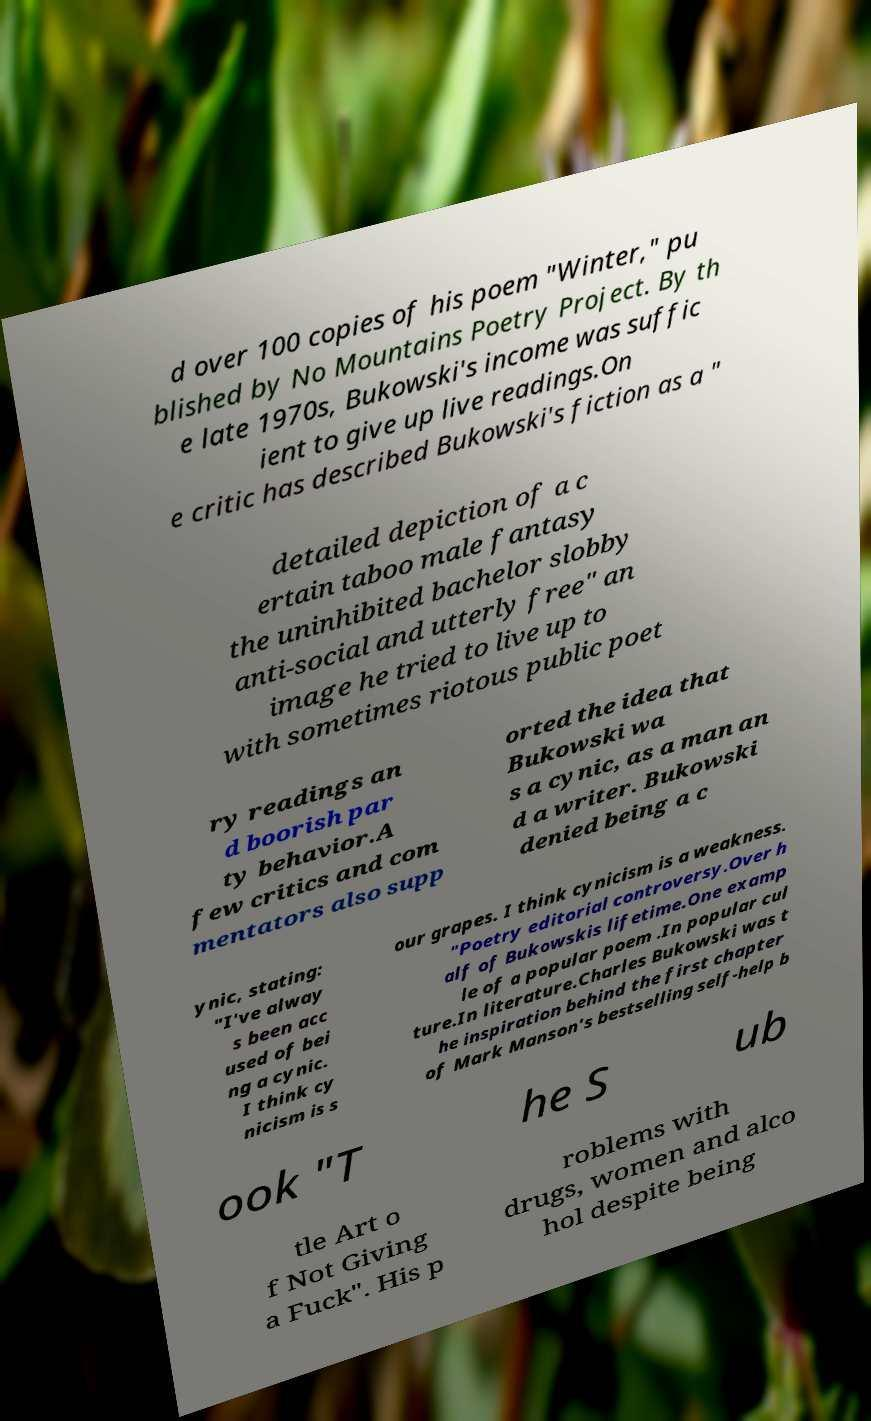Can you accurately transcribe the text from the provided image for me? d over 100 copies of his poem "Winter," pu blished by No Mountains Poetry Project. By th e late 1970s, Bukowski's income was suffic ient to give up live readings.On e critic has described Bukowski's fiction as a " detailed depiction of a c ertain taboo male fantasy the uninhibited bachelor slobby anti-social and utterly free" an image he tried to live up to with sometimes riotous public poet ry readings an d boorish par ty behavior.A few critics and com mentators also supp orted the idea that Bukowski wa s a cynic, as a man an d a writer. Bukowski denied being a c ynic, stating: "I've alway s been acc used of bei ng a cynic. I think cy nicism is s our grapes. I think cynicism is a weakness. "Poetry editorial controversy.Over h alf of Bukowskis lifetime.One examp le of a popular poem .In popular cul ture.In literature.Charles Bukowski was t he inspiration behind the first chapter of Mark Manson's bestselling self-help b ook "T he S ub tle Art o f Not Giving a Fuck". His p roblems with drugs, women and alco hol despite being 